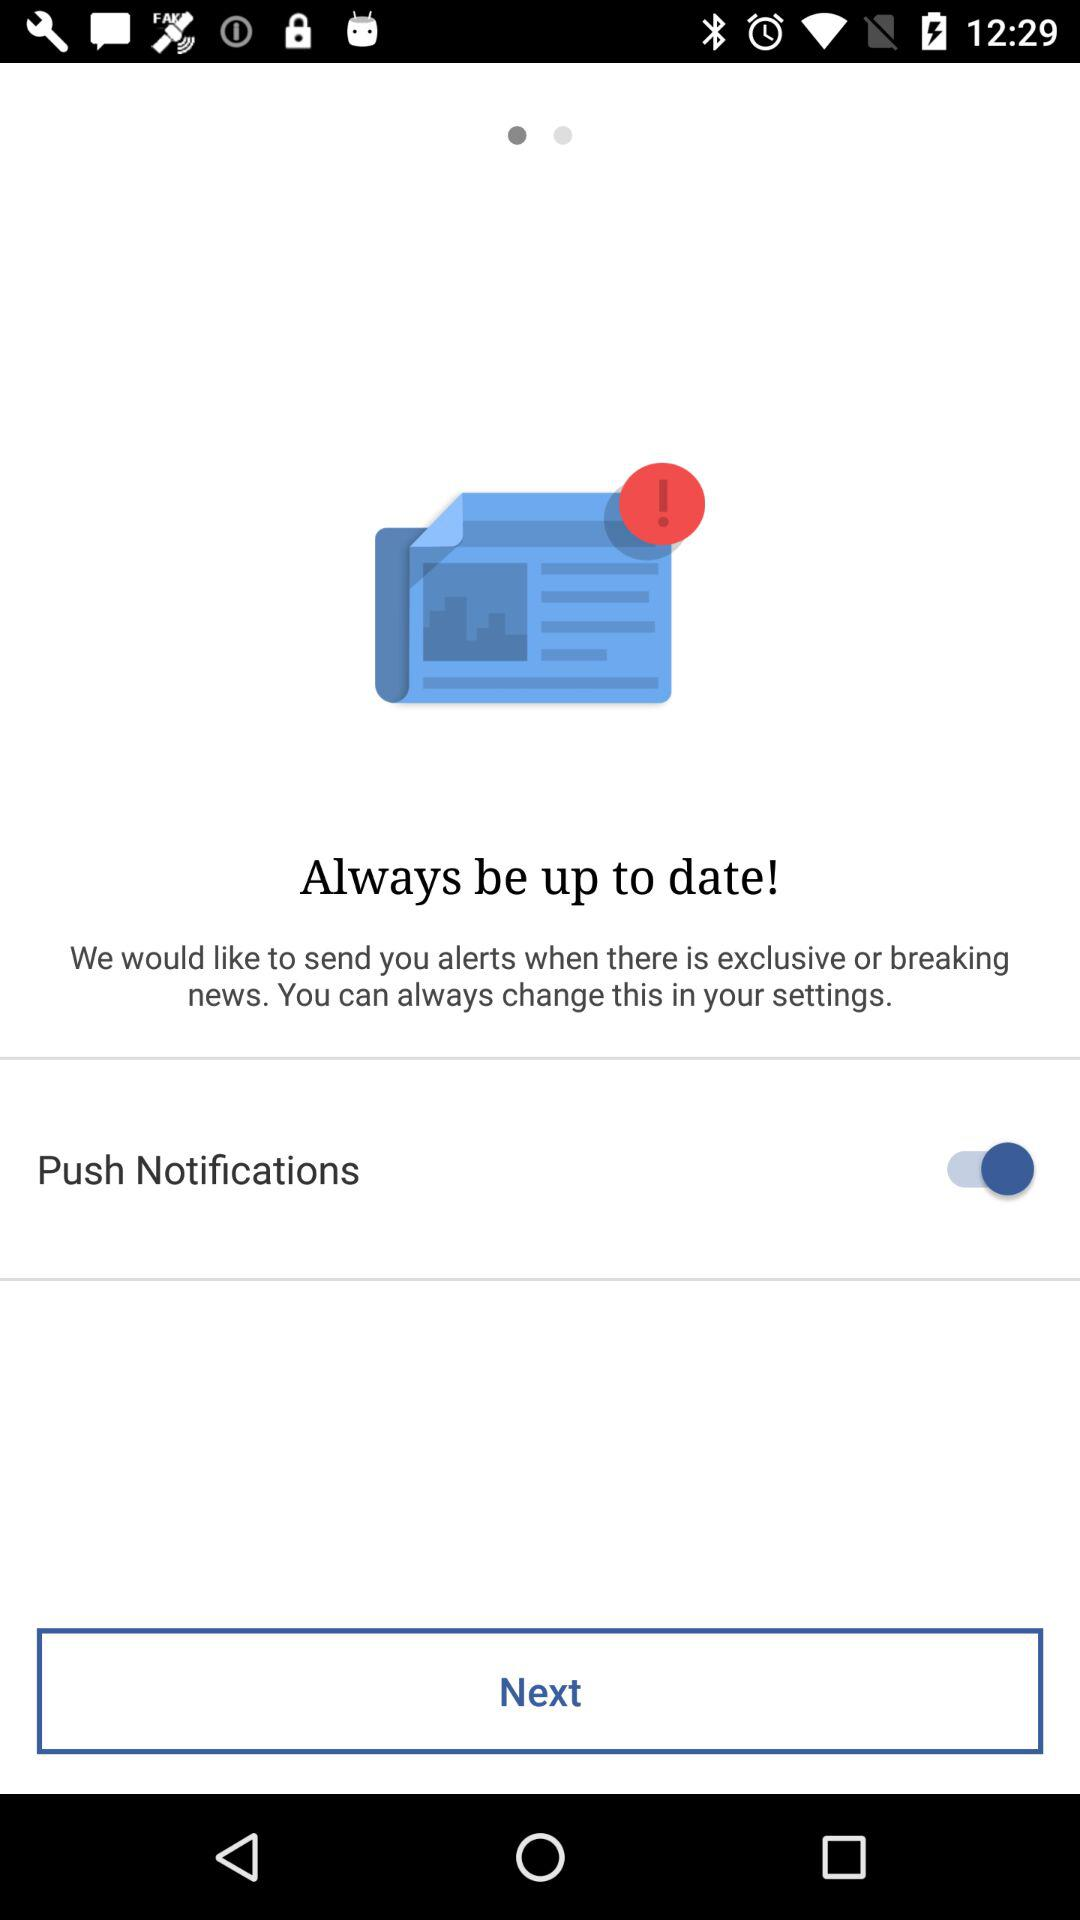What is the status of "Push Notifications"? The status is "on". 